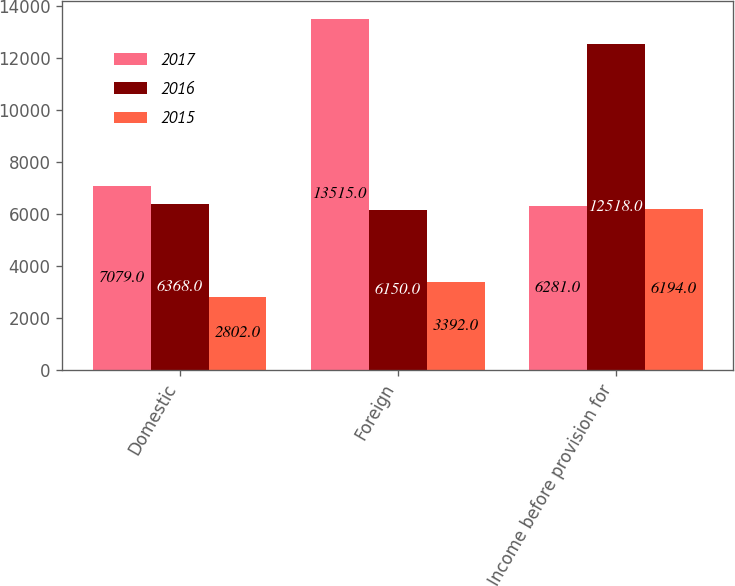<chart> <loc_0><loc_0><loc_500><loc_500><stacked_bar_chart><ecel><fcel>Domestic<fcel>Foreign<fcel>Income before provision for<nl><fcel>2017<fcel>7079<fcel>13515<fcel>6281<nl><fcel>2016<fcel>6368<fcel>6150<fcel>12518<nl><fcel>2015<fcel>2802<fcel>3392<fcel>6194<nl></chart> 